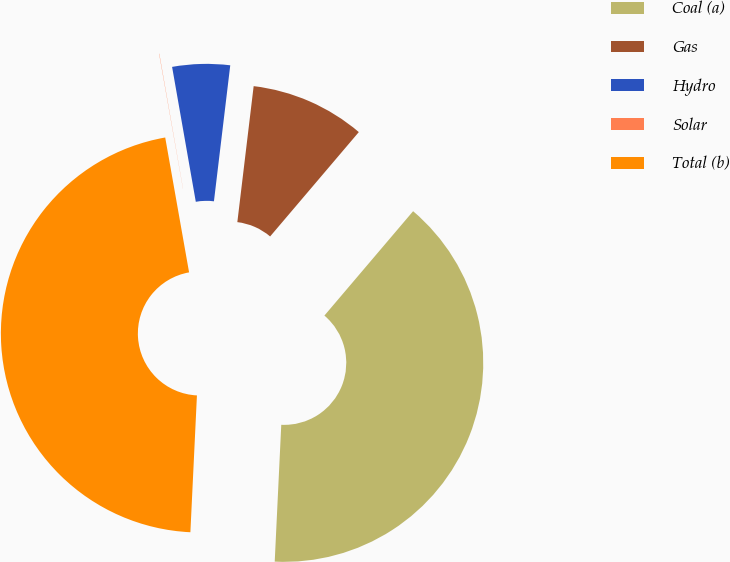<chart> <loc_0><loc_0><loc_500><loc_500><pie_chart><fcel>Coal (a)<fcel>Gas<fcel>Hydro<fcel>Solar<fcel>Total (b)<nl><fcel>39.55%<fcel>9.31%<fcel>4.67%<fcel>0.02%<fcel>46.45%<nl></chart> 